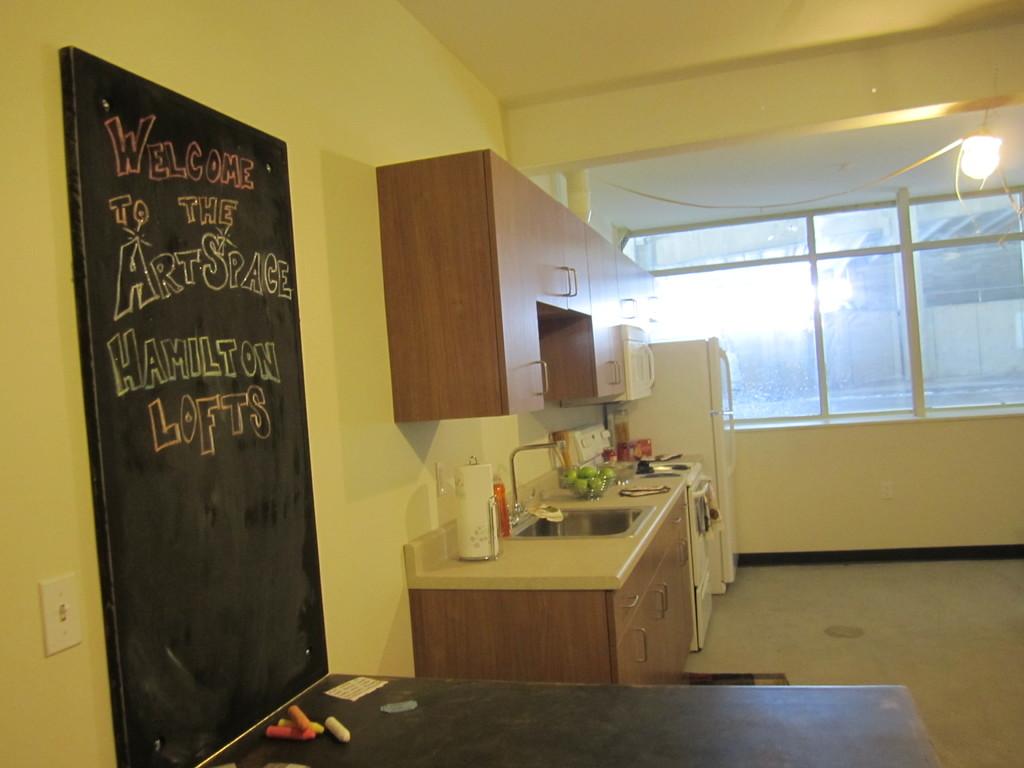Where is the art space?
Offer a terse response. Hamilton lofts. What space is on the left?
Give a very brief answer. Art space. 